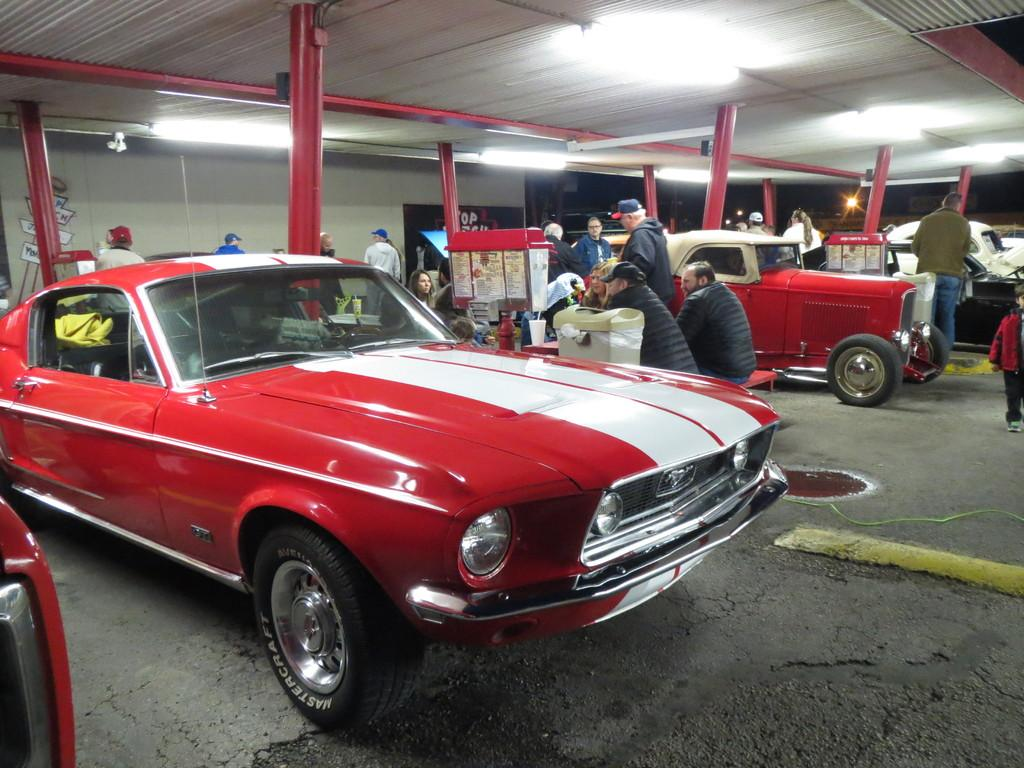What type of view is shown in the image? The image is an inside view. What can be seen inside the location? There are cars, people, poles, and bins visible in the image. What is located at the top of the image? There is a light at the top of the image. Can you see a minister giving a speech in the image? There is no minister or speech present in the image. Is there a sofa in the image? There is no sofa visible in the image. 